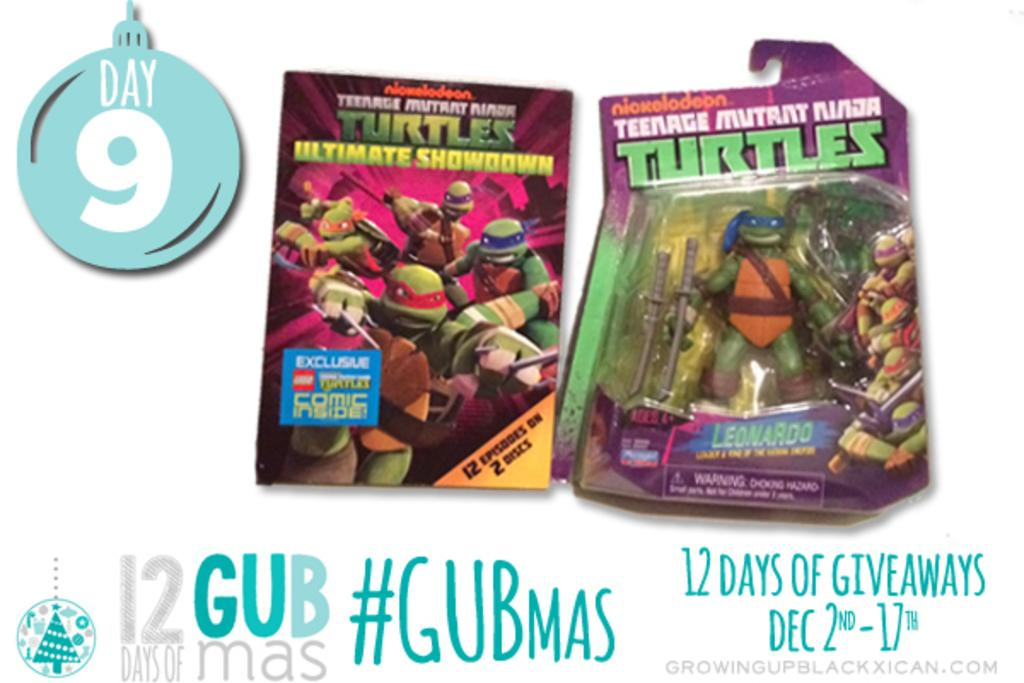What is featured on the poster in the image? The poster contains pictures of turtles. Is there any text on the poster? Yes, there is text present on the poster. Can you identify any numbers in the image? Yes, there are numbers visible in the image. What type of surprise can be seen in the image? There is no surprise present in the image; it features a poster with pictures of turtles and text. Can you see a goat in the image? No, there is no goat present in the image. 